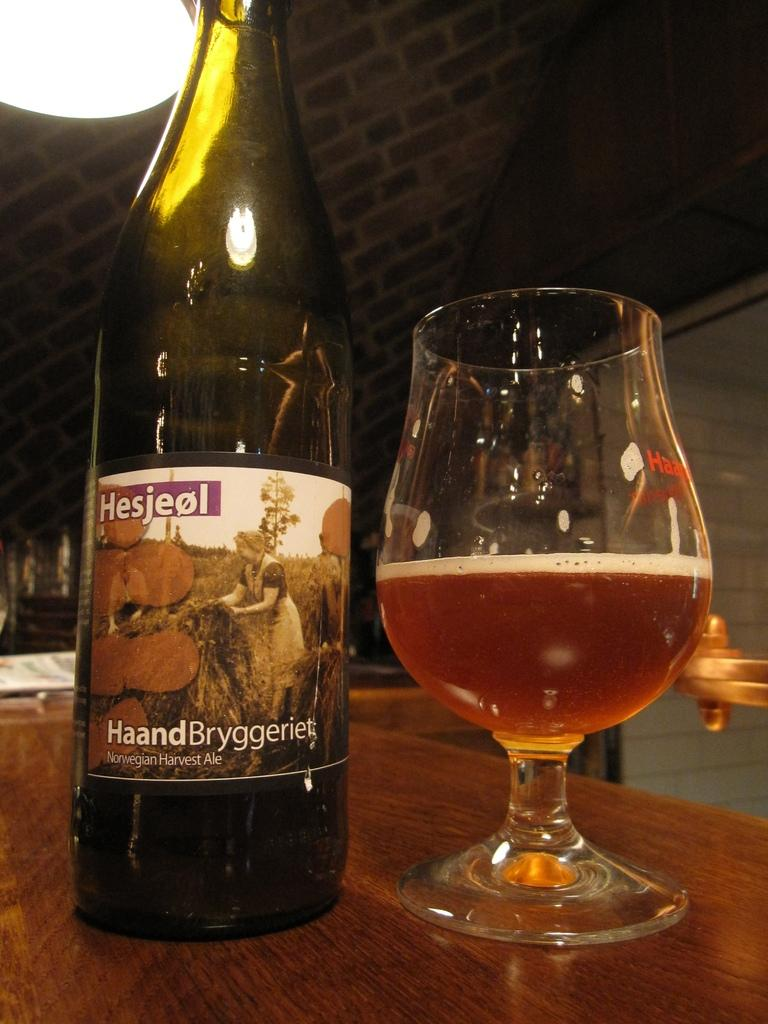Provide a one-sentence caption for the provided image. Bottle of Hesjeol beer next to a half cup of beer. 